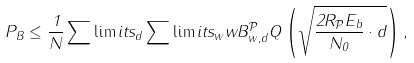Convert formula to latex. <formula><loc_0><loc_0><loc_500><loc_500>P _ { B } \leq \frac { 1 } { N } \sum \lim i t s _ { d } \sum \lim i t s _ { w } w B ^ { \mathcal { P } } _ { w , d } Q \left ( \sqrt { \frac { 2 R _ { \mathcal { P } } E _ { b } } { N _ { 0 } } \cdot d } \right ) ,</formula> 